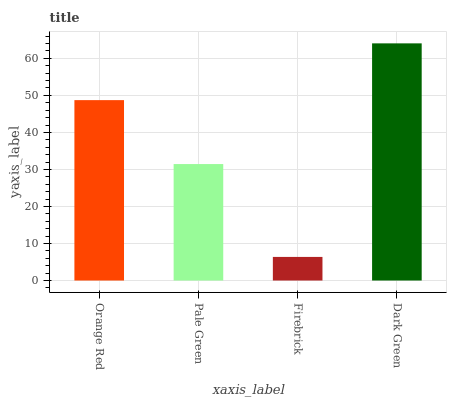Is Pale Green the minimum?
Answer yes or no. No. Is Pale Green the maximum?
Answer yes or no. No. Is Orange Red greater than Pale Green?
Answer yes or no. Yes. Is Pale Green less than Orange Red?
Answer yes or no. Yes. Is Pale Green greater than Orange Red?
Answer yes or no. No. Is Orange Red less than Pale Green?
Answer yes or no. No. Is Orange Red the high median?
Answer yes or no. Yes. Is Pale Green the low median?
Answer yes or no. Yes. Is Pale Green the high median?
Answer yes or no. No. Is Dark Green the low median?
Answer yes or no. No. 